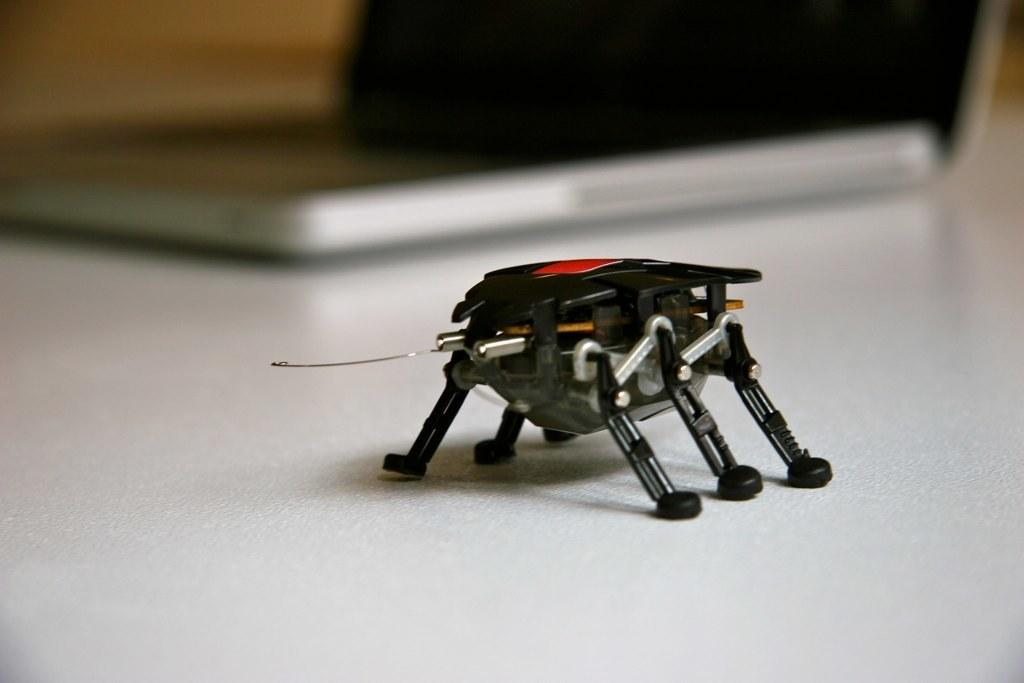What is the main object on the platform in the image? The fact sheet does not specify the object on the platform, so we cannot definitively answer this question. Can you describe the laptop in the background of the image? The fact sheet only mentions the presence of a laptop in the background, but it does not provide any details about the laptop itself. How many ducks are swimming in the stew in the image? There are no ducks or stew present in the image. Are the brothers in the image arguing over the laptop? The fact sheet does not mention any brothers or any argument in the image, so we cannot answer this question. 